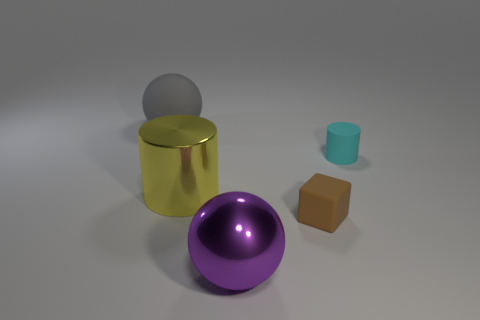Add 1 rubber objects. How many objects exist? 6 Subtract all blocks. How many objects are left? 4 Subtract all balls. Subtract all large purple spheres. How many objects are left? 2 Add 1 tiny cyan rubber objects. How many tiny cyan rubber objects are left? 2 Add 3 large yellow shiny spheres. How many large yellow shiny spheres exist? 3 Subtract 0 blue cubes. How many objects are left? 5 